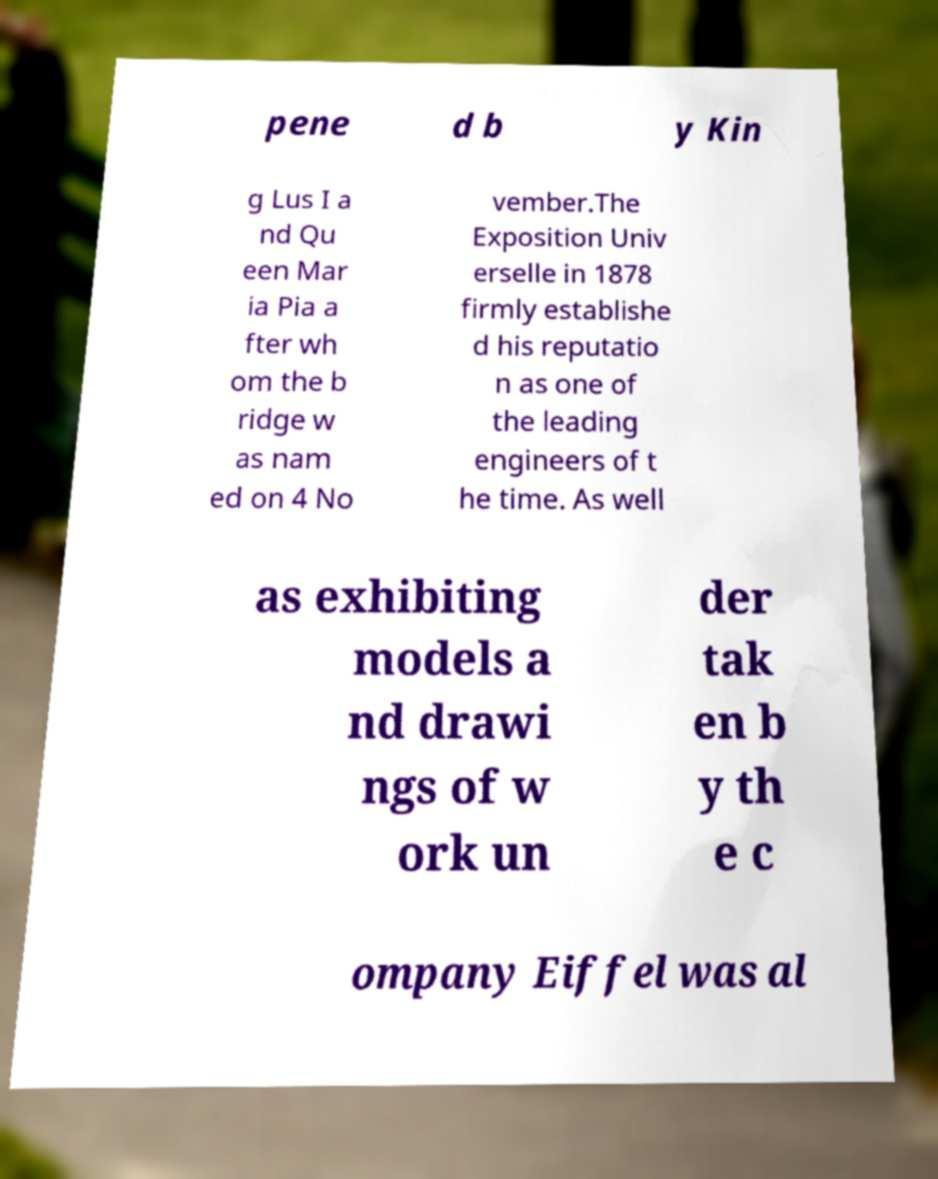Please identify and transcribe the text found in this image. pene d b y Kin g Lus I a nd Qu een Mar ia Pia a fter wh om the b ridge w as nam ed on 4 No vember.The Exposition Univ erselle in 1878 firmly establishe d his reputatio n as one of the leading engineers of t he time. As well as exhibiting models a nd drawi ngs of w ork un der tak en b y th e c ompany Eiffel was al 